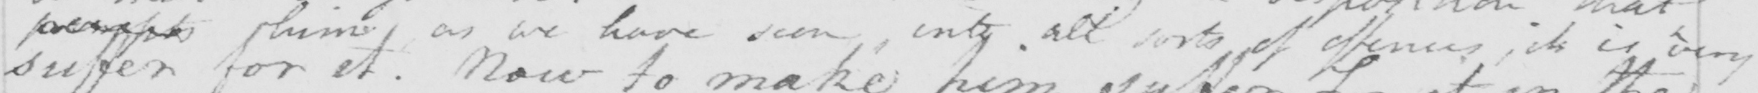What text is written in this handwritten line? <gap/>  him as we have seen , into all sorts of offences , it is very 